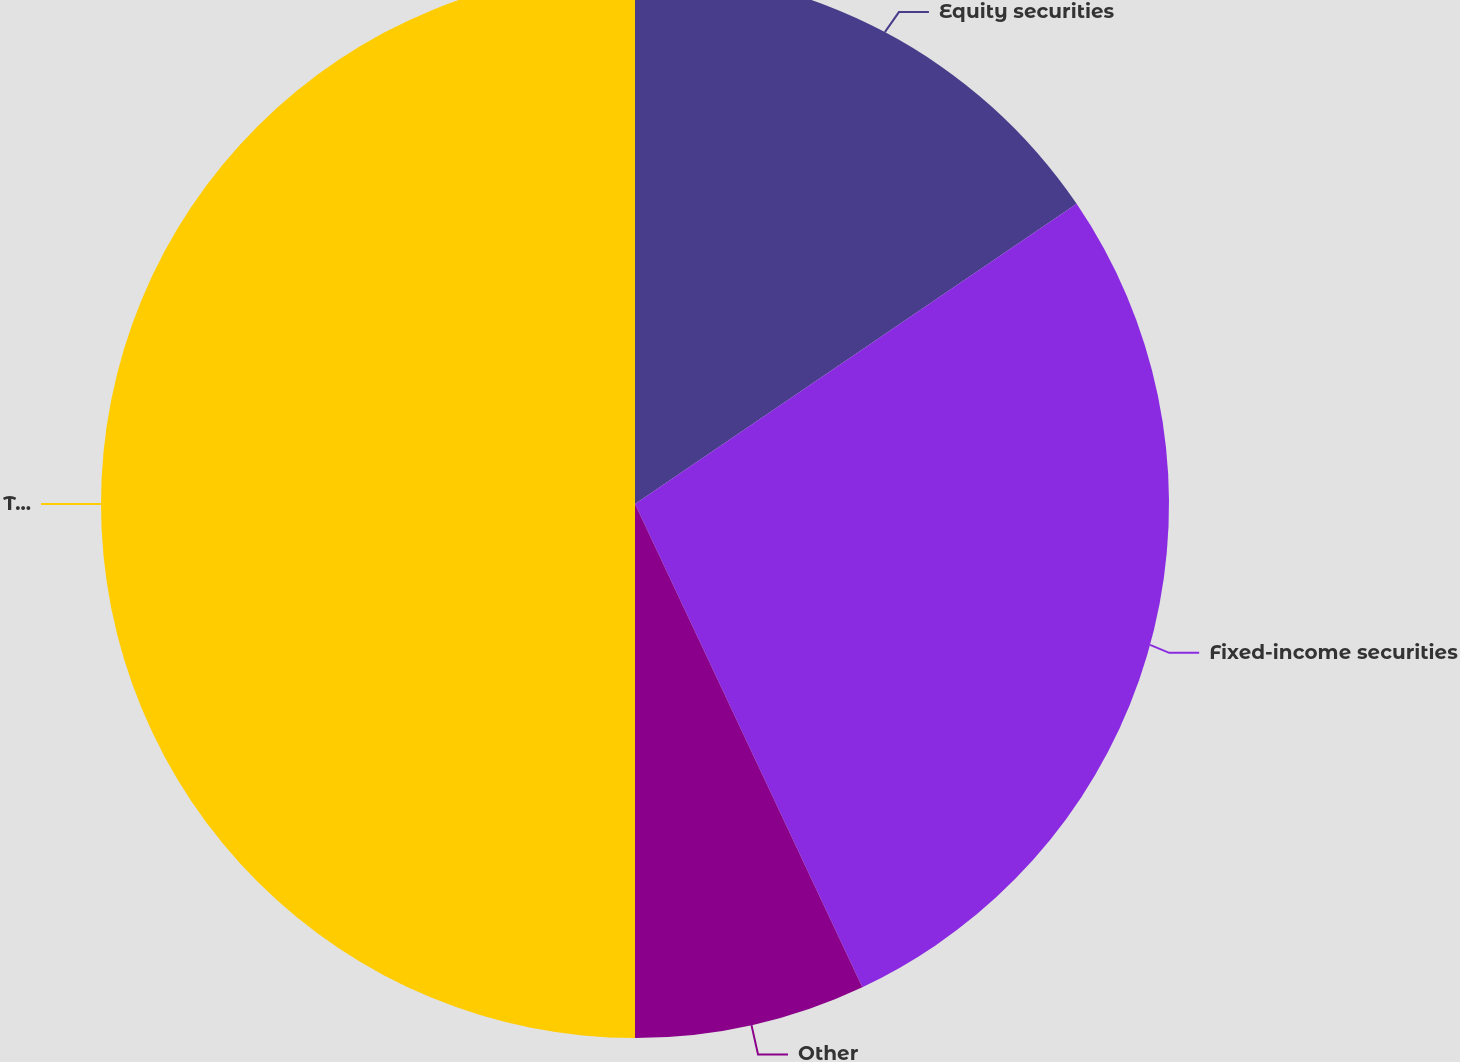<chart> <loc_0><loc_0><loc_500><loc_500><pie_chart><fcel>Equity securities<fcel>Fixed-income securities<fcel>Other<fcel>Total<nl><fcel>15.5%<fcel>27.5%<fcel>7.0%<fcel>50.0%<nl></chart> 